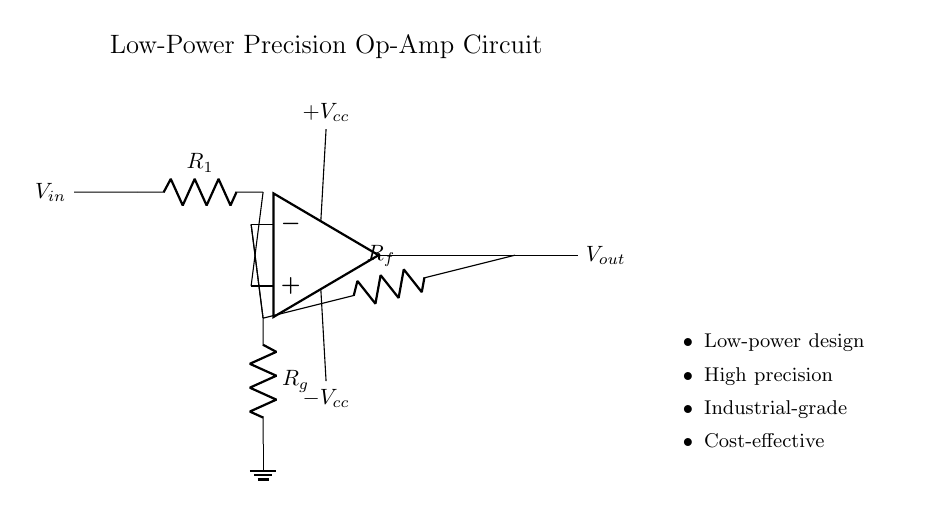What is the input voltage of the circuit? The input voltage is labeled as V_in, which is indicated on the left side of the circuit diagram.
Answer: V_in What type of feedback is used in this circuit? The circuit employs negative feedback as indicated by the connection from the output to the inverting input terminal (opamp.-). Negative feedback stabilizes and controls the gain of the op-amp.
Answer: Negative feedback What are the values of the resistors used in the circuit? The resistors in the circuit are labeled as R1, Rf, and Rg, with no numerical values provided in the diagram. They categorize the circuit components without specifying exact resistance values.
Answer: R1, Rf, Rg What power supply voltages are used in this circuit? The power supply provides +V_cc and -V_cc, which are the positive and negative supply voltages respectively. These voltages are crucial for the operation of the op-amp circuit.
Answer: +V_cc and -V_cc How does this circuit achieve precision sensing? The circuit achieves precision sensing through the use of a low-power operational amplifier designed for high precision applications. The choice of components and configuration minimizes errors and enhances the accuracy of the output signal.
Answer: High precision What is the primary function of this circuit? The primary function of this circuit is to amplify the input signal V_in for precise sensing applications, demonstrating its role in industrial equipment.
Answer: Amplification What category of circuits does this circuit diagram belong to? This circuit belongs to the category of analog circuits, specifically focusing on low-power operational amplifier designs for precision measurements.
Answer: Analog 